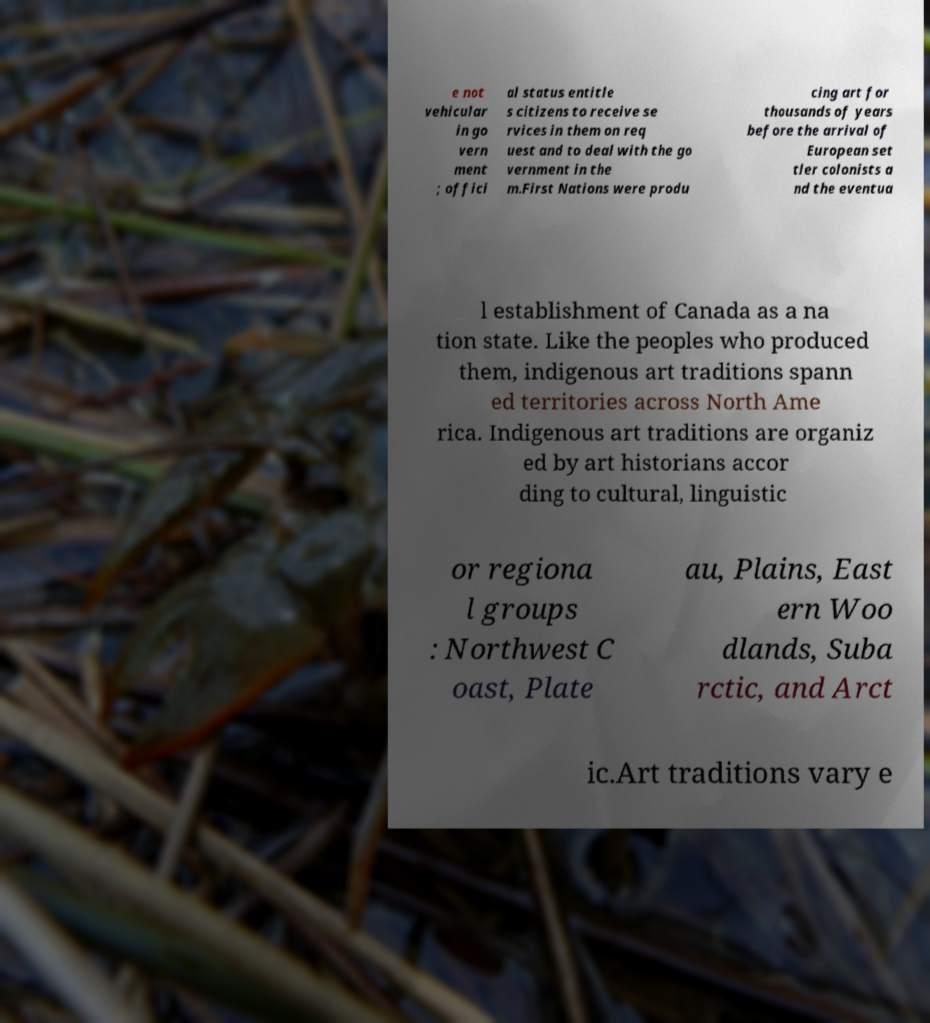I need the written content from this picture converted into text. Can you do that? e not vehicular in go vern ment ; offici al status entitle s citizens to receive se rvices in them on req uest and to deal with the go vernment in the m.First Nations were produ cing art for thousands of years before the arrival of European set tler colonists a nd the eventua l establishment of Canada as a na tion state. Like the peoples who produced them, indigenous art traditions spann ed territories across North Ame rica. Indigenous art traditions are organiz ed by art historians accor ding to cultural, linguistic or regiona l groups : Northwest C oast, Plate au, Plains, East ern Woo dlands, Suba rctic, and Arct ic.Art traditions vary e 